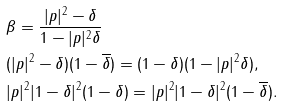Convert formula to latex. <formula><loc_0><loc_0><loc_500><loc_500>& \beta = \frac { | p | ^ { 2 } - \delta } { 1 - | p | ^ { 2 } \delta } \\ & ( | p | ^ { 2 } - \delta ) ( 1 - \overline { \delta } ) = ( 1 - \delta ) ( 1 - | p | ^ { 2 } \delta ) , \\ & | p | ^ { 2 } | 1 - \delta | ^ { 2 } ( 1 - \delta ) = | p | ^ { 2 } | 1 - \delta | ^ { 2 } ( 1 - \overline { \delta } ) .</formula> 